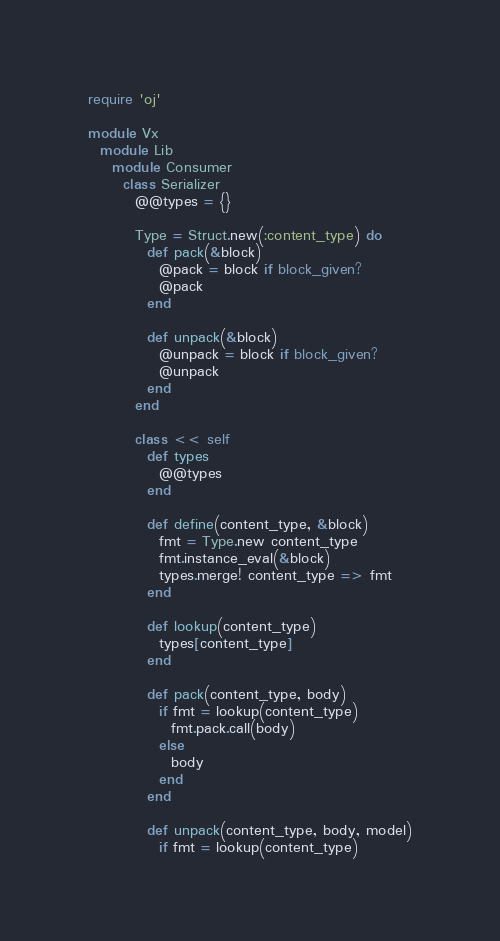Convert code to text. <code><loc_0><loc_0><loc_500><loc_500><_Ruby_>require 'oj'

module Vx
  module Lib
    module Consumer
      class Serializer
        @@types = {}

        Type = Struct.new(:content_type) do
          def pack(&block)
            @pack = block if block_given?
            @pack
          end

          def unpack(&block)
            @unpack = block if block_given?
            @unpack
          end
        end

        class << self
          def types
            @@types
          end

          def define(content_type, &block)
            fmt = Type.new content_type
            fmt.instance_eval(&block)
            types.merge! content_type => fmt
          end

          def lookup(content_type)
            types[content_type]
          end

          def pack(content_type, body)
            if fmt = lookup(content_type)
              fmt.pack.call(body)
            else
              body
            end
          end

          def unpack(content_type, body, model)
            if fmt = lookup(content_type)</code> 